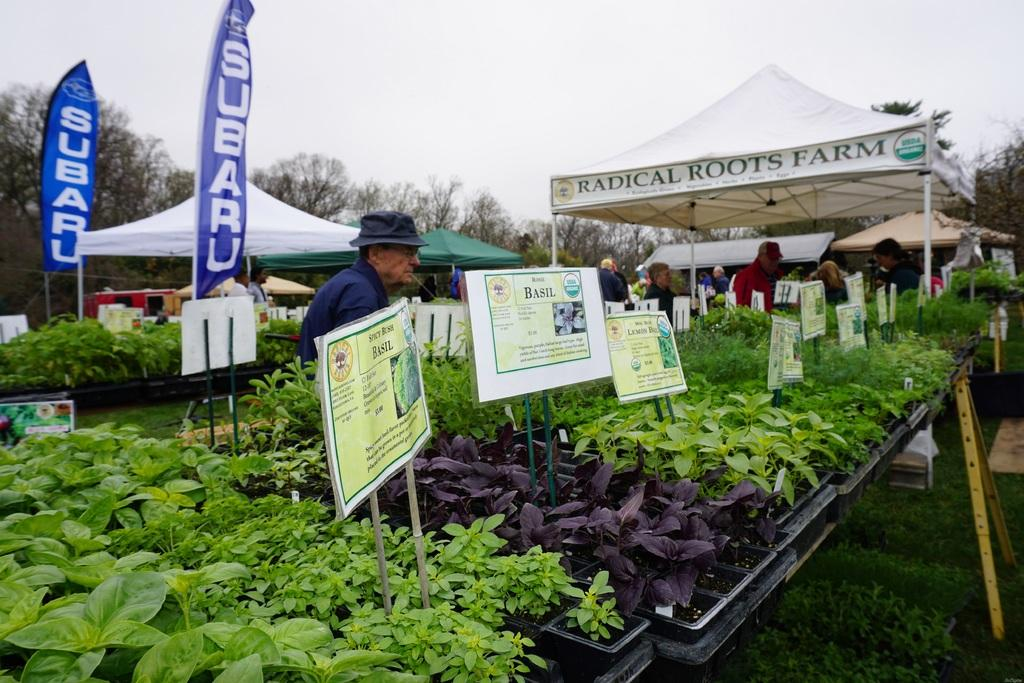What type of natural elements can be seen in the image? There are plants and trees visible in the image. What part of the natural environment is visible in the image? The sky is visible in the image. What type of man-made structures are present in the image? There are posters and a tent visible in the image. Are there any people in the image? Yes, there are people present in the image. What type of string is being used by the people in the image? There is no string visible in the image. What action are the people performing with the gun in the image? There is no gun present in the image, so no such action can be observed. 